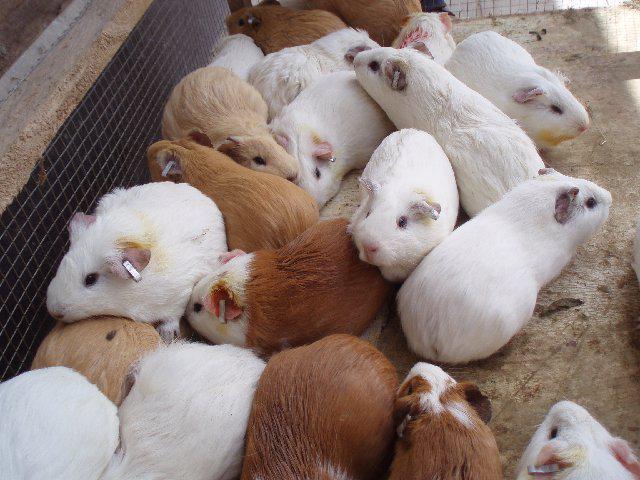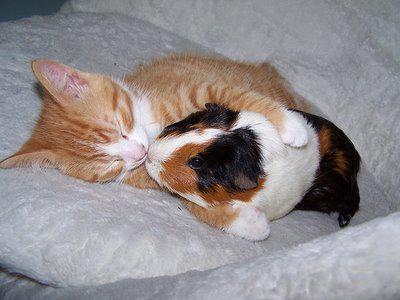The first image is the image on the left, the second image is the image on the right. Given the left and right images, does the statement "There are at least three rodents in the image on the left." hold true? Answer yes or no. Yes. The first image is the image on the left, the second image is the image on the right. Considering the images on both sides, is "One image shows a hamster laying with an animal that is not a hamster." valid? Answer yes or no. Yes. 